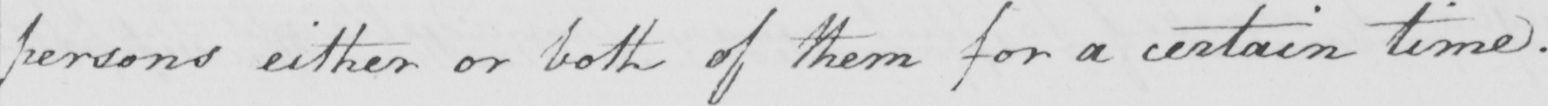Can you tell me what this handwritten text says? persons either or both of them for a certain time . 